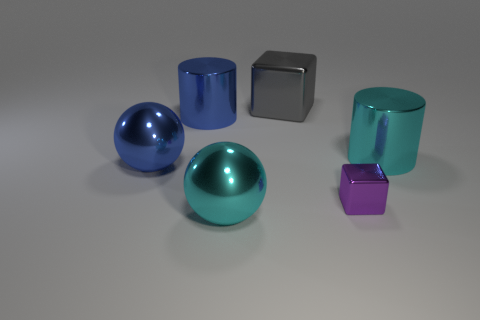Add 2 big cyan metal cylinders. How many objects exist? 8 Subtract all blocks. How many objects are left? 4 Add 1 blue things. How many blue things are left? 3 Add 1 metallic balls. How many metallic balls exist? 3 Subtract 0 yellow cubes. How many objects are left? 6 Subtract all blue rubber cubes. Subtract all large shiny objects. How many objects are left? 1 